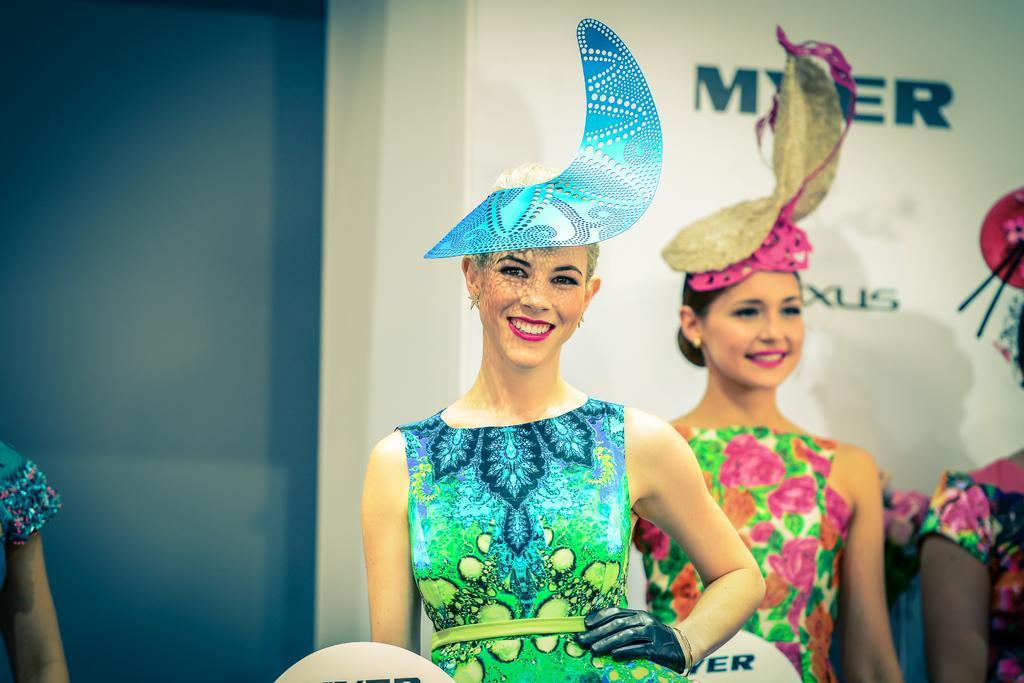Can you describe this image briefly? In this image, I can see two women standing and smiling. They wore fancy dresses. In the background, that looks like a banner. On the right side of the image, I can see another person standing. At the bottom image, I think these are the boards. On the left corner of the image, I can see a person´s hand. 